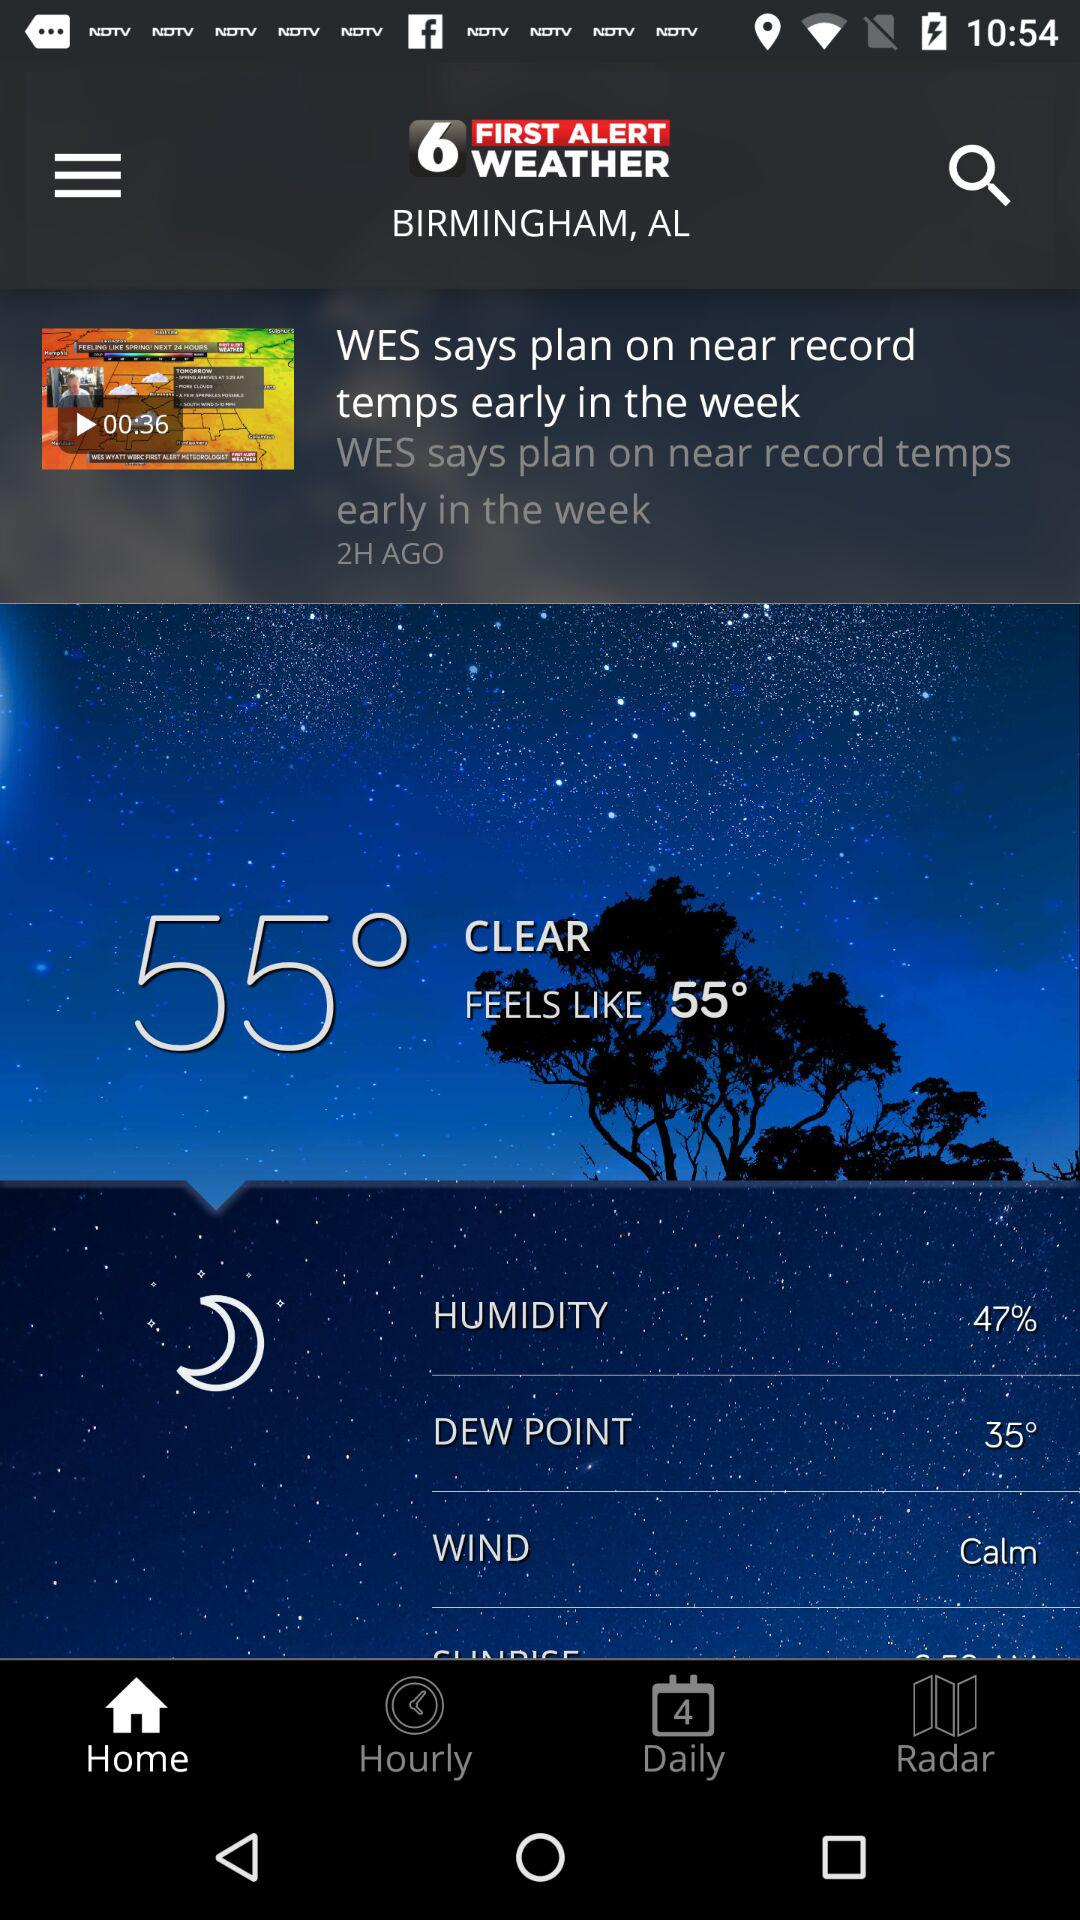How many degrees Fahrenheit is the dew point?
Answer the question using a single word or phrase. 35° 